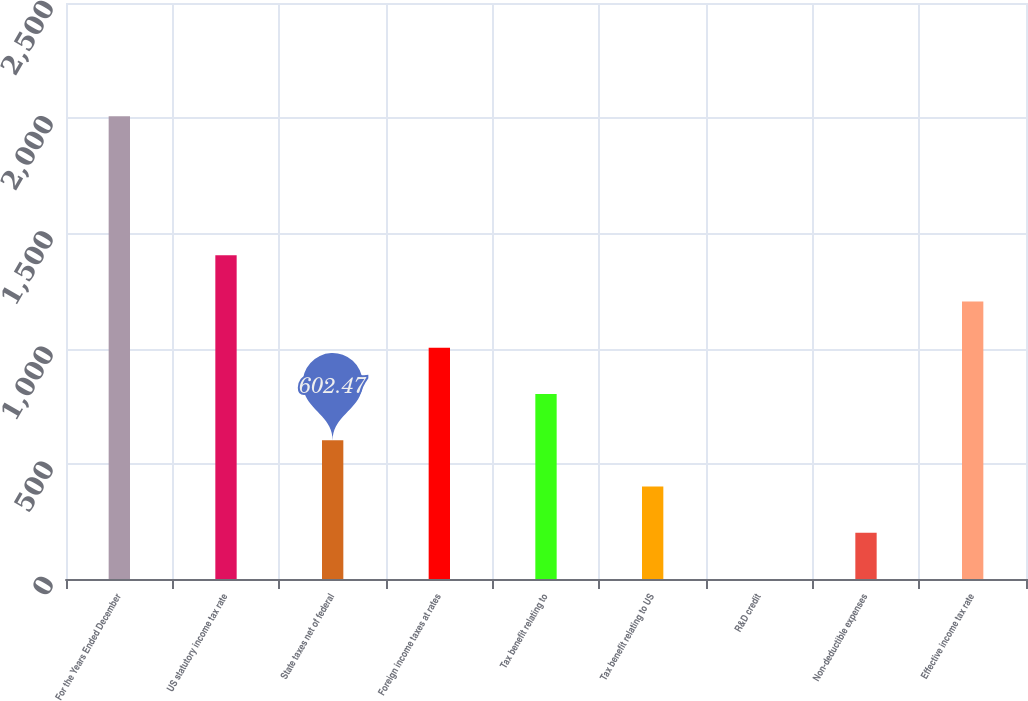<chart> <loc_0><loc_0><loc_500><loc_500><bar_chart><fcel>For the Years Ended December<fcel>US statutory income tax rate<fcel>State taxes net of federal<fcel>Foreign income taxes at rates<fcel>Tax benefit relating to<fcel>Tax benefit relating to US<fcel>R&D credit<fcel>Non-deductible expenses<fcel>Effective income tax rate<nl><fcel>2008<fcel>1405.63<fcel>602.47<fcel>1004.05<fcel>803.26<fcel>401.68<fcel>0.1<fcel>200.89<fcel>1204.84<nl></chart> 